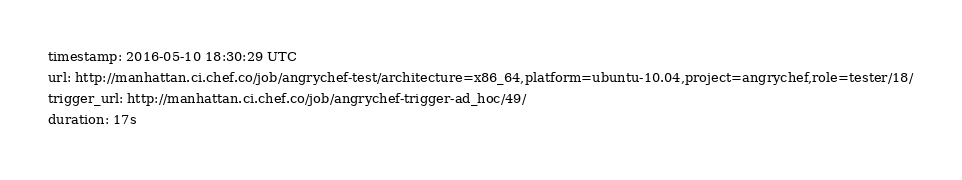<code> <loc_0><loc_0><loc_500><loc_500><_YAML_>timestamp: 2016-05-10 18:30:29 UTC
url: http://manhattan.ci.chef.co/job/angrychef-test/architecture=x86_64,platform=ubuntu-10.04,project=angrychef,role=tester/18/
trigger_url: http://manhattan.ci.chef.co/job/angrychef-trigger-ad_hoc/49/
duration: 17s
</code> 